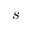<formula> <loc_0><loc_0><loc_500><loc_500>s</formula> 